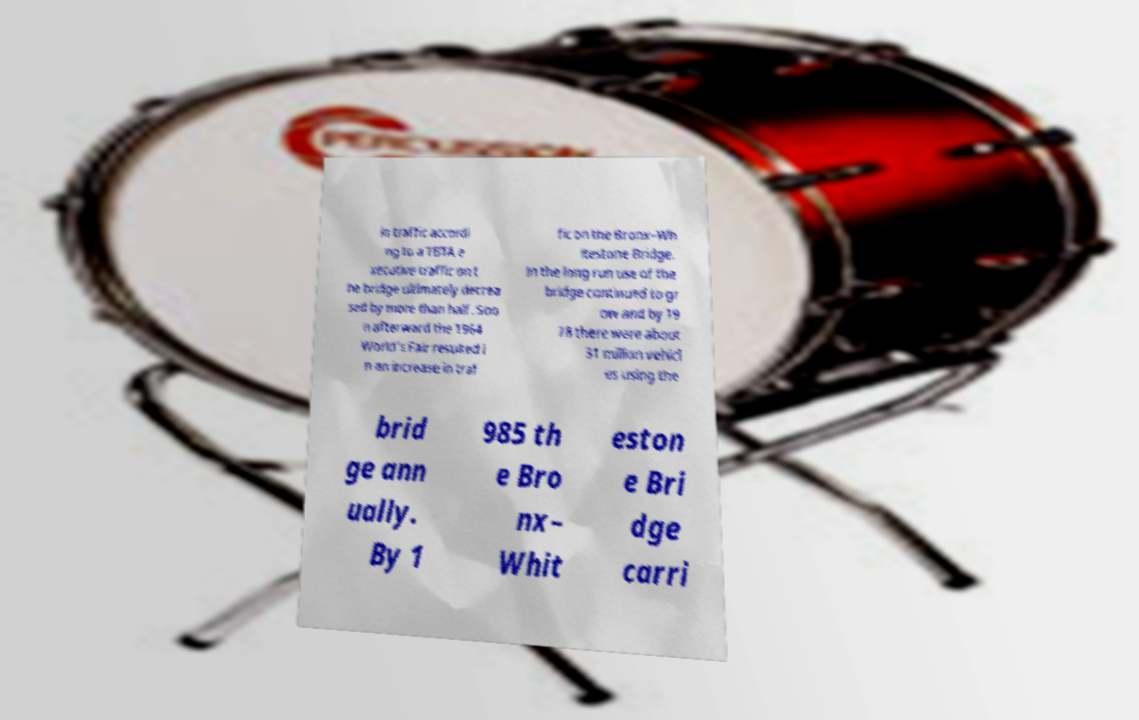Please read and relay the text visible in this image. What does it say? in traffic accordi ng to a TBTA e xecutive traffic on t he bridge ultimately decrea sed by more than half. Soo n afterward the 1964 World's Fair resulted i n an increase in traf fic on the Bronx–Wh itestone Bridge. In the long run use of the bridge continued to gr ow and by 19 78 there were about 31 million vehicl es using the brid ge ann ually. By 1 985 th e Bro nx– Whit eston e Bri dge carri 